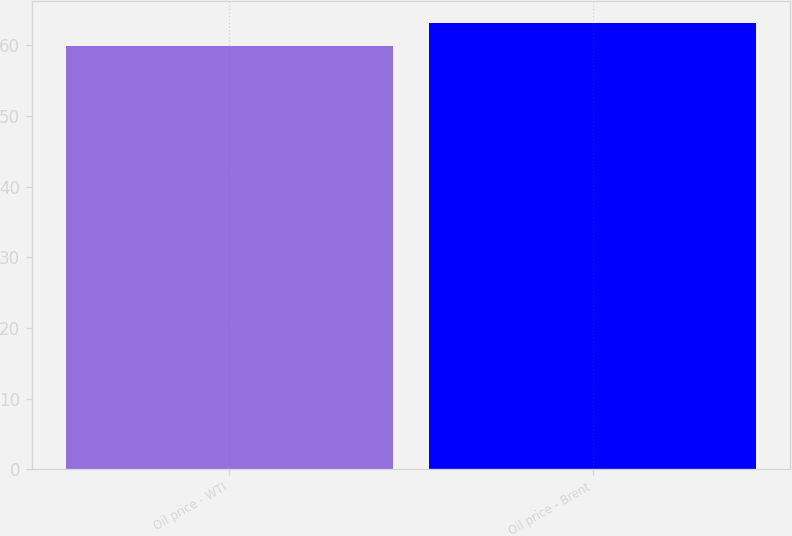Convert chart. <chart><loc_0><loc_0><loc_500><loc_500><bar_chart><fcel>Oil price - WTI<fcel>Oil price - Brent<nl><fcel>59.95<fcel>63.07<nl></chart> 